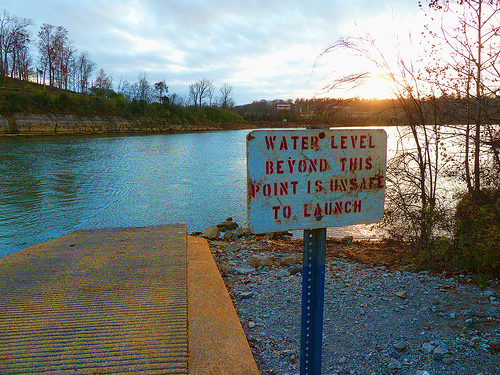<image>
Is the sign in front of the ramp? Yes. The sign is positioned in front of the ramp, appearing closer to the camera viewpoint. 